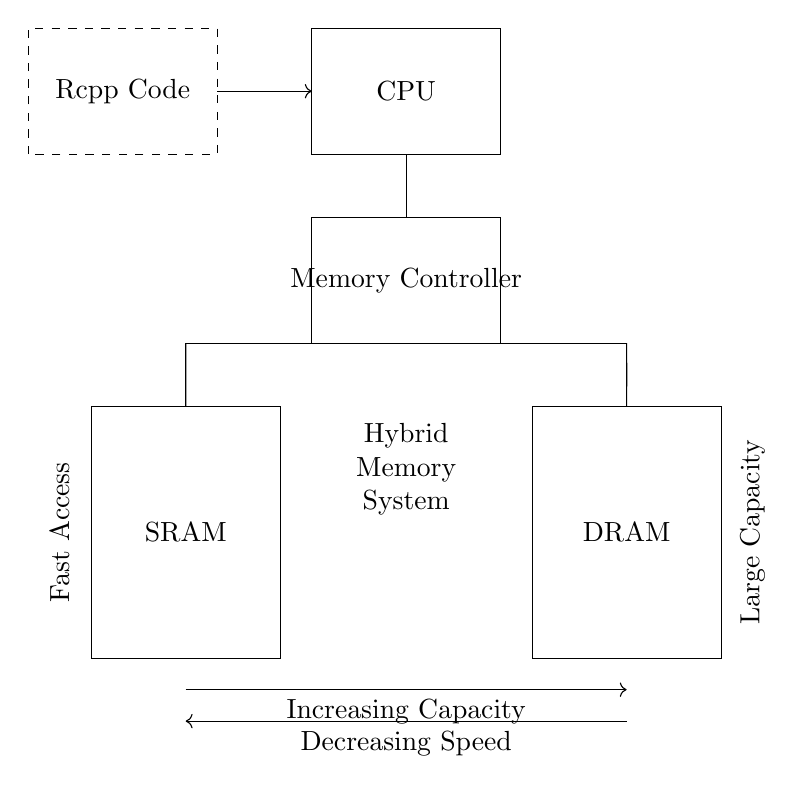What components are present in the circuit? The circuit contains SRAM, DRAM, a memory controller, and a CPU. These components are visually distinct within their respective rectangles.
Answer: SRAM, DRAM, Memory Controller, CPU What does the dashed rectangle represent? The dashed rectangle represents the Rcpp code, indicating where the software executes in relation to the hardware components. It is labeled in the diagram and feeds into the CPU.
Answer: Rcpp Code Which memory type is designed for fast access? The SRAM component is identified in the diagram and is typically used for faster access due to its static nature. The label "Fast Access" next to the SRAM further confirms this.
Answer: SRAM How does increasing capacity affect speed in this system? The diagram shows a downward arrow with "Decreasing Speed" beside it marked at the SRAM, which indicates that as capacity is increased, the speed of access to memory may decrease, particularly in DRAM.
Answer: Decreasing Speed What is the role of the memory controller in this circuit? The memory controller manages data flow between the CPU, SRAM, and DRAM, facilitating communication and optimizing memory access, as represented by its central position in the diagram.
Answer: Memory Management What connection exists between the SRAM and the memory controller? The diagram shows a single direct connection line between the SRAM and the memory controller, indicating that data can flow from the SRAM to the controller for processing by the CPU.
Answer: Direct Connection Which memory type offers larger capacity? The DRAM component is shown to be larger and is commonly known for its ability to store more data due to its dynamic nature, which is visually suggested by the labels on the respective memory types.
Answer: DRAM 